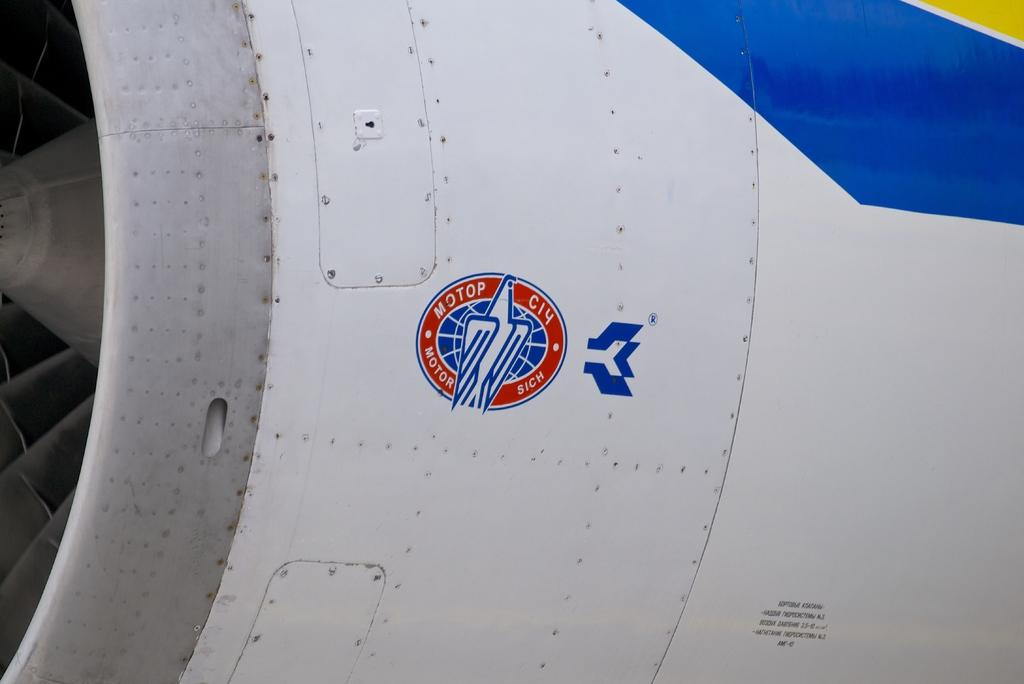What is the main subject of the image? The main subject of the image is the outer surface of an aeroplane. Can you describe any specific features of the aeroplane in the image? Unfortunately, the provided facts do not mention any specific features of the aeroplane. Is there any indication of the aeroplane's location or surroundings in the image? No, the image only shows the outer surface of the aeroplane, and there is no information about its location or surroundings. Can you tell me how many cups the stranger is holding in the image? There is no stranger or cup present in the image; it only shows the outer surface of an aeroplane. 